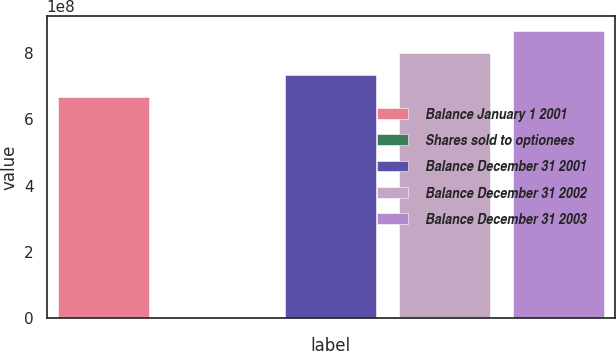Convert chart to OTSL. <chart><loc_0><loc_0><loc_500><loc_500><bar_chart><fcel>Balance January 1 2001<fcel>Shares sold to optionees<fcel>Balance December 31 2001<fcel>Balance December 31 2002<fcel>Balance December 31 2003<nl><fcel>6.67086e+08<fcel>8385<fcel>7.33796e+08<fcel>8.00505e+08<fcel>8.67215e+08<nl></chart> 